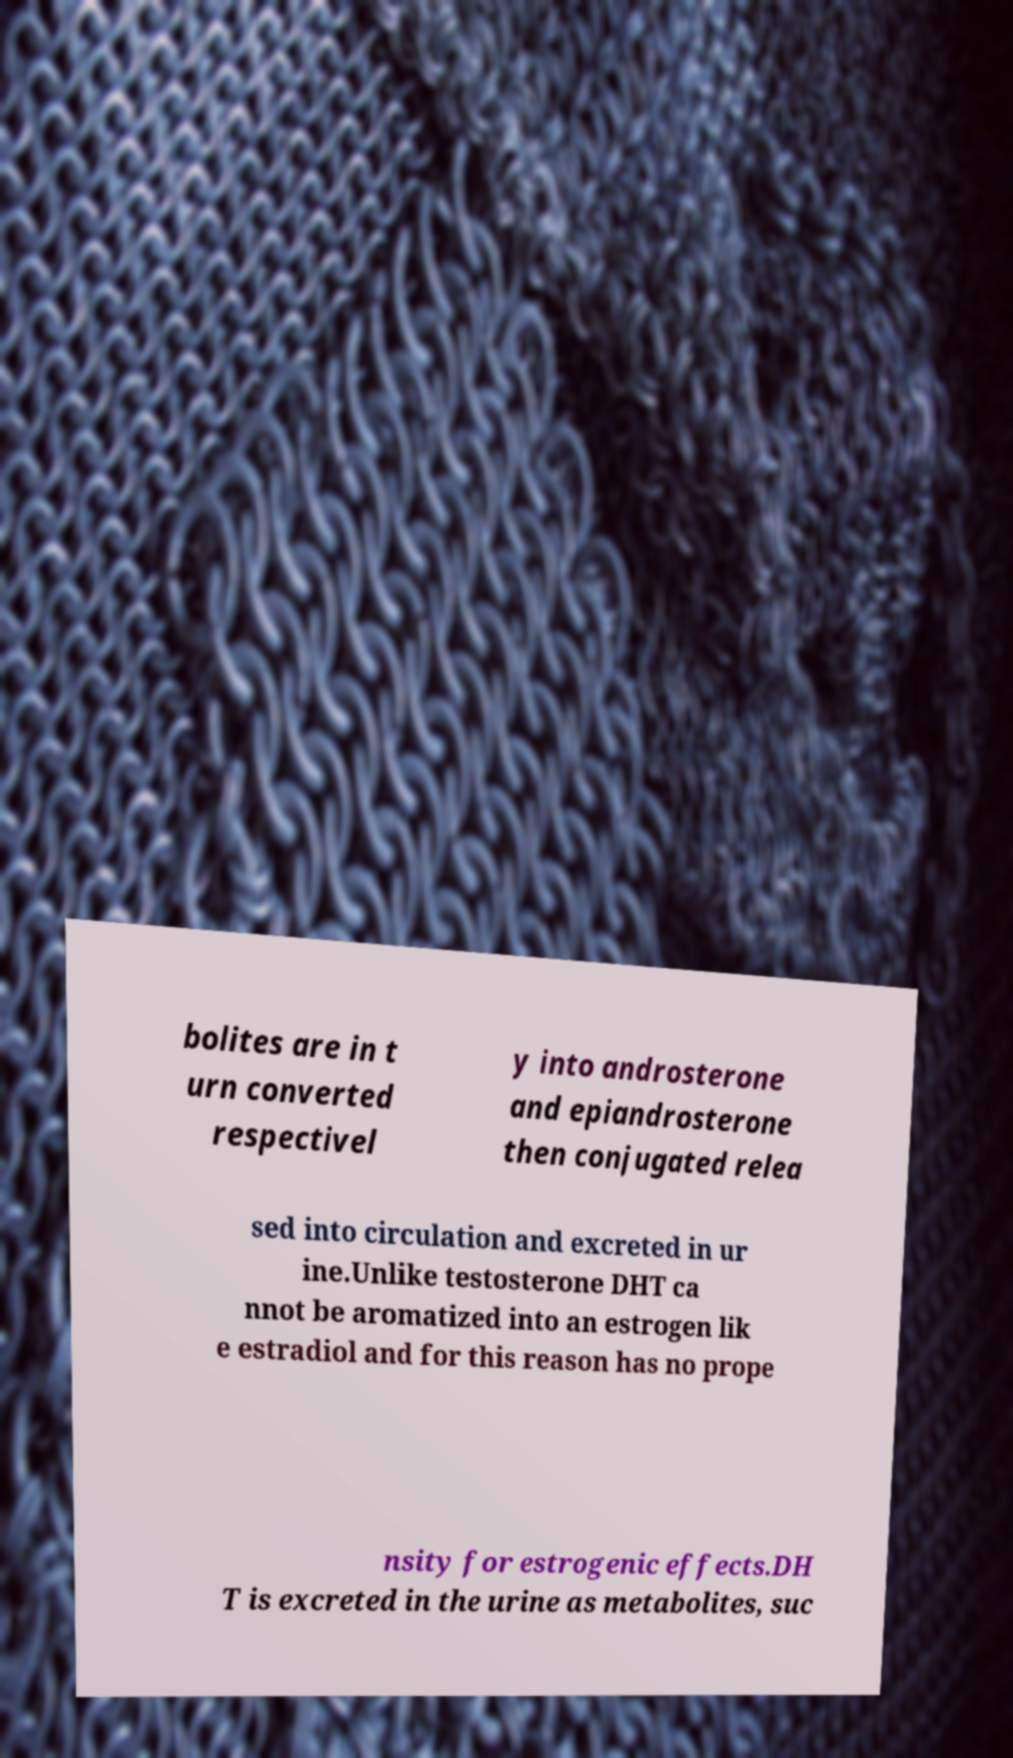For documentation purposes, I need the text within this image transcribed. Could you provide that? bolites are in t urn converted respectivel y into androsterone and epiandrosterone then conjugated relea sed into circulation and excreted in ur ine.Unlike testosterone DHT ca nnot be aromatized into an estrogen lik e estradiol and for this reason has no prope nsity for estrogenic effects.DH T is excreted in the urine as metabolites, suc 